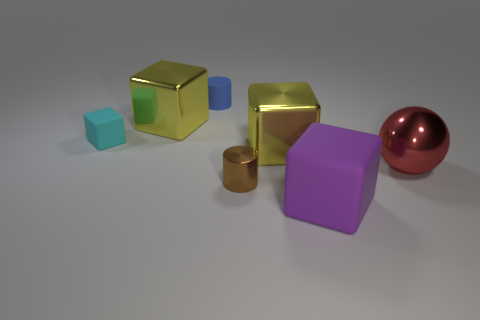Add 1 yellow metallic objects. How many objects exist? 8 Subtract all tiny cubes. How many cubes are left? 3 Subtract all brown cylinders. How many yellow cubes are left? 2 Subtract all blocks. How many objects are left? 3 Subtract all cyan cubes. How many cubes are left? 3 Subtract 2 cubes. How many cubes are left? 2 Subtract all small cylinders. Subtract all purple things. How many objects are left? 4 Add 2 red metal spheres. How many red metal spheres are left? 3 Add 5 big metal blocks. How many big metal blocks exist? 7 Subtract 1 red spheres. How many objects are left? 6 